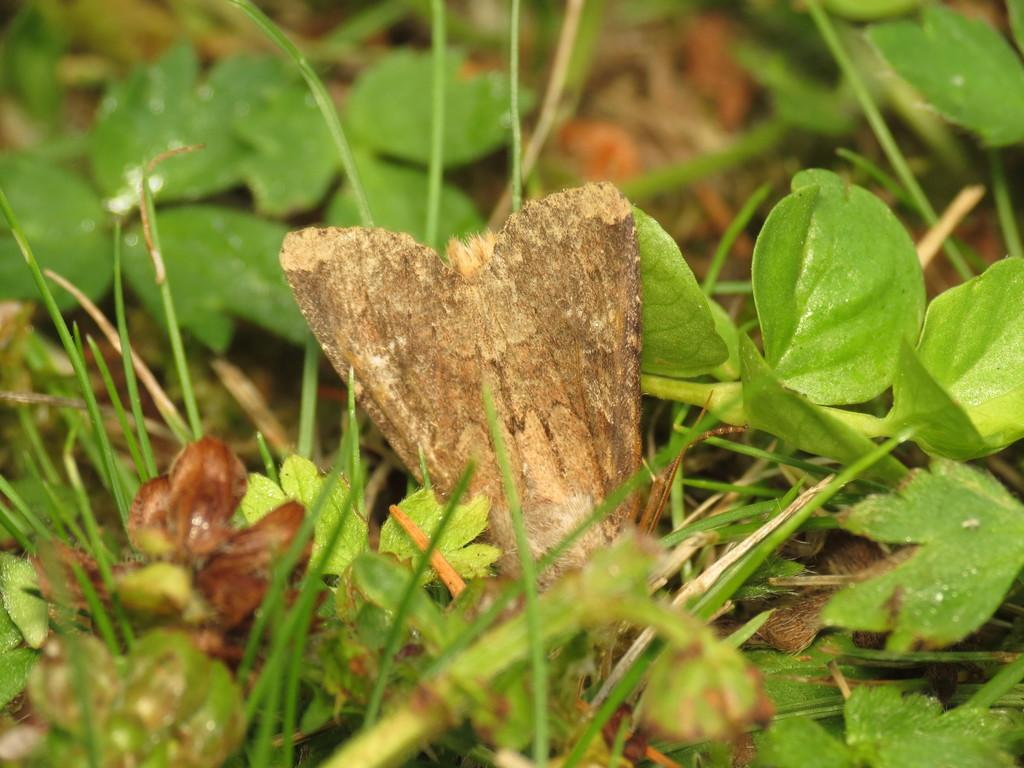What is the main object in the middle of the image? There is a brown color object in the middle of the image. What type of natural environment is depicted in the image? The image contains grass, leaves, and sand, suggesting a natural environment. What type of relation is shown between the chairs and the table in the image? There are no chairs or table present in the image, so no such relation can be observed. 